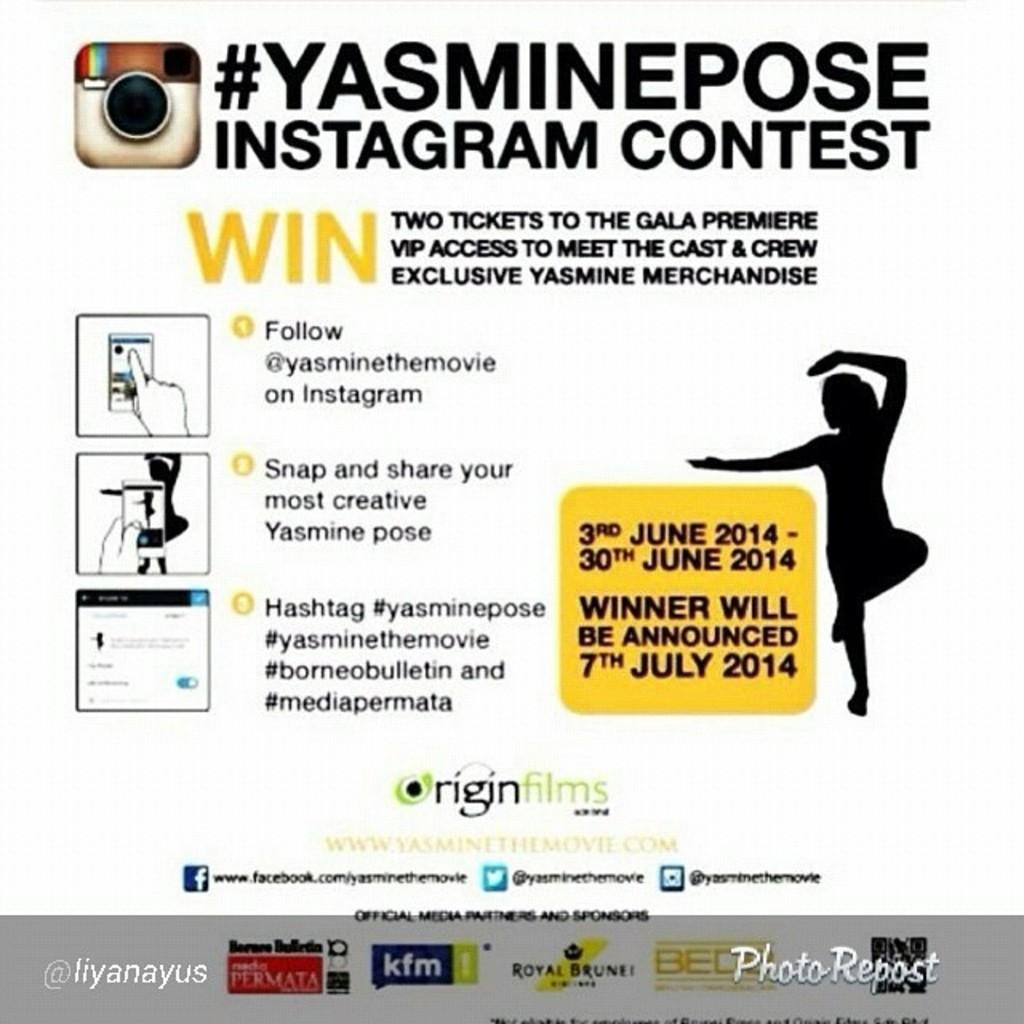What is the main subject of the paper in the image? A person is depicted on the paper. Are there any other objects or elements on the paper? Yes, a camera is depicted on the paper. Are there any words written on the paper? Yes, there are words written on the paper. How many friends are shown exchanging stockings in the image? There are no friends or stockings present in the image; it only features a paper with a person and a camera depicted on it. 